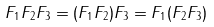<formula> <loc_0><loc_0><loc_500><loc_500>F _ { 1 } F _ { 2 } F _ { 3 } = ( F _ { 1 } F _ { 2 } ) F _ { 3 } = F _ { 1 } ( F _ { 2 } F _ { 3 } )</formula> 